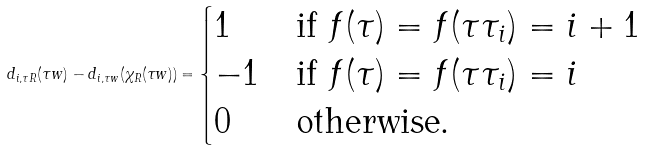<formula> <loc_0><loc_0><loc_500><loc_500>d _ { i , \tau R } ( \tau w ) - d _ { i , \tau w } ( \chi _ { R } ( \tau w ) ) = \begin{cases} 1 & \text {if $f(\tau)=f(\tau \tau_{i})=i+1$} \\ - 1 & \text {if $f(\tau)=f(\tau \tau_{i})=i$} \\ 0 & \text {otherwise.} \end{cases}</formula> 